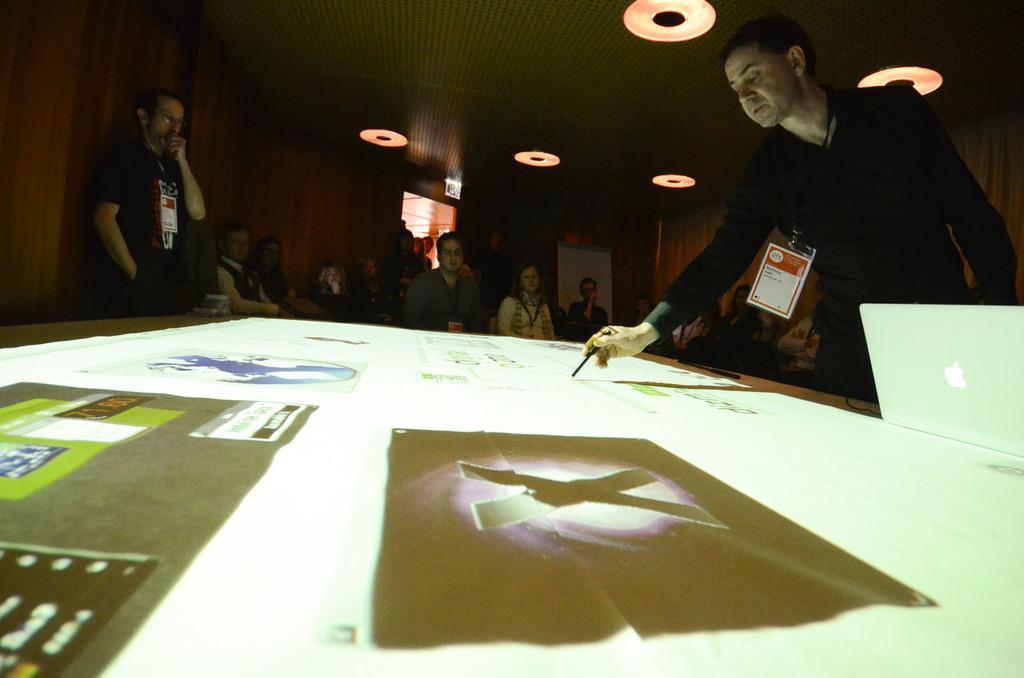How would you summarize this image in a sentence or two? In this picture we can see a man presenting something to a group of people, he is pointing his pen to something, in the background we can see group of people sitting and looking at the presentation, on left side we can see a man wearing identity card and we can see some of the lights here, right side of picture we can see laptop. 